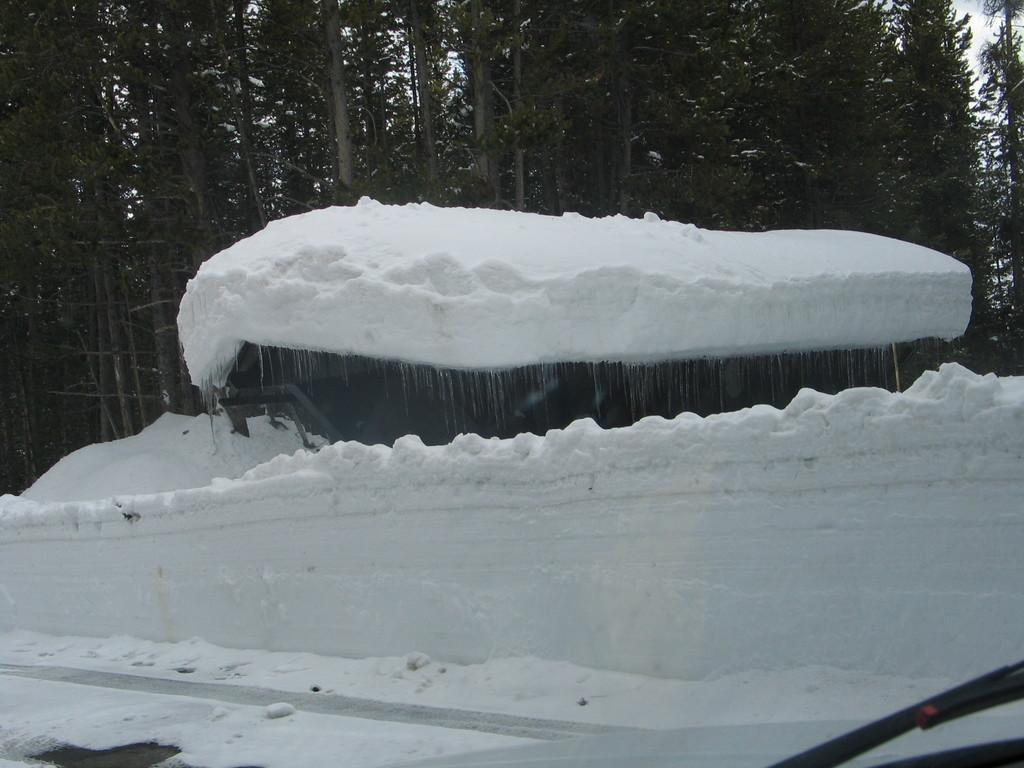What is the primary feature of the image? There is snow in the image. What can be seen in the background of the image? There are trees in the background of the image. What type of class is being held in the snow in the image? There is no class or any indication of a class being held in the image; it simply shows snow and trees. 